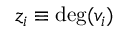<formula> <loc_0><loc_0><loc_500><loc_500>z _ { i } \equiv \deg ( v _ { i } )</formula> 